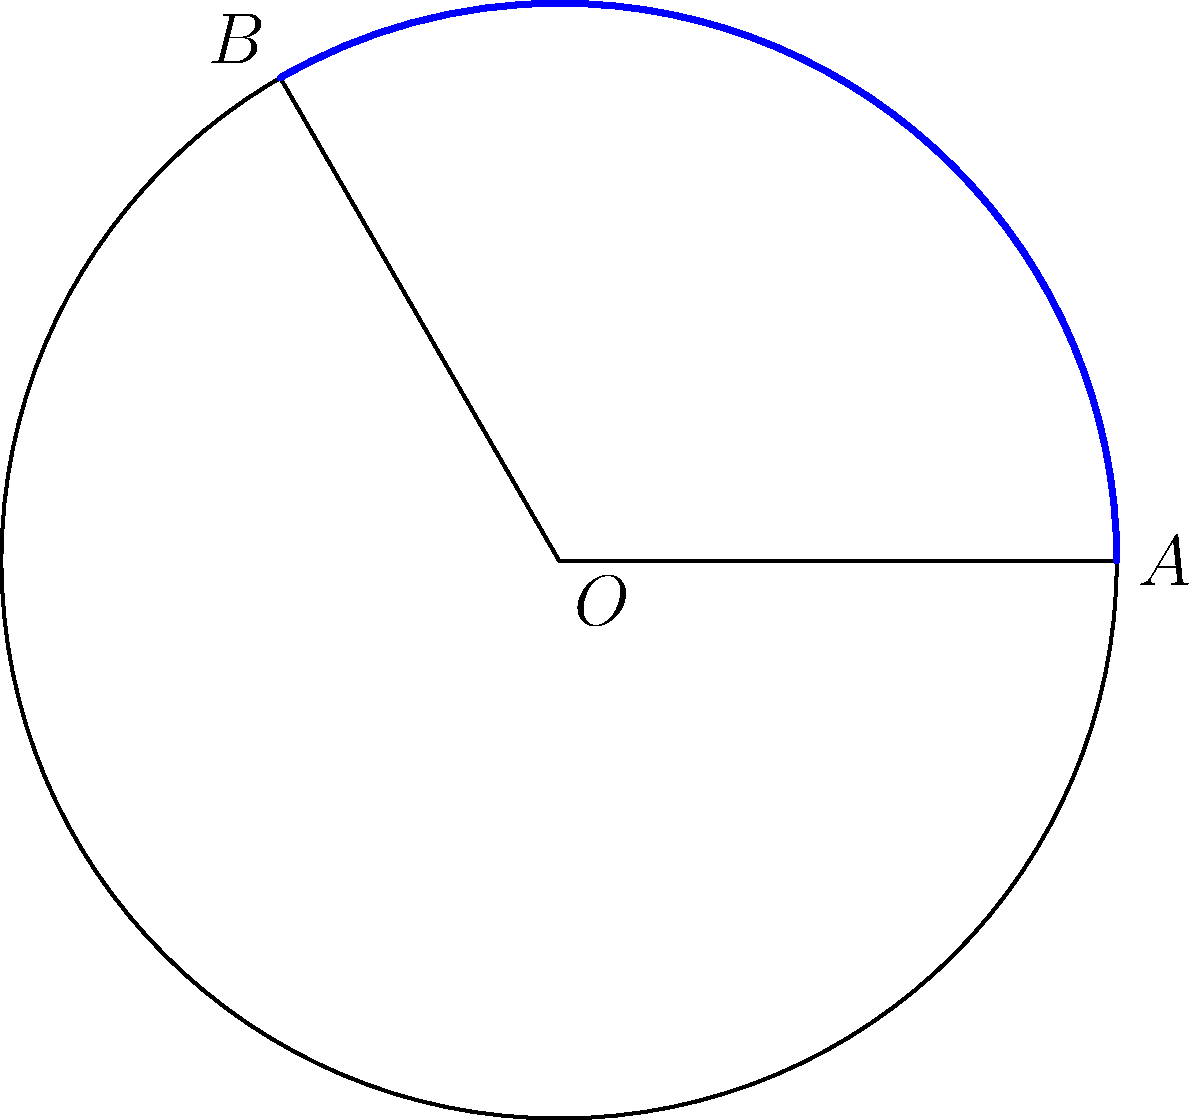In a swimming stroke analysis, the arc of a swimmer's hand movement is modeled as a circular segment. If the radius of this circular path is 0.75 meters and the central angle of the arc is 120°, what is the length of the arc (in meters) that the swimmer's hand travels during this portion of the stroke? To calculate the arc length, we can use the formula:

$$ s = r\theta $$

Where:
- $s$ is the arc length
- $r$ is the radius of the circle
- $\theta$ is the central angle in radians

Steps:
1) We have the radius $r = 0.75$ meters
2) The angle is given as 120°, but we need to convert it to radians:
   $$ \theta = 120° \times \frac{\pi}{180°} = \frac{2\pi}{3} \text{ radians} $$
3) Now we can substitute these values into our formula:
   $$ s = 0.75 \times \frac{2\pi}{3} $$
4) Simplify:
   $$ s = 0.5\pi \text{ meters} $$
5) To get a decimal approximation:
   $$ s \approx 1.57 \text{ meters} $$

Therefore, the swimmer's hand travels approximately 1.57 meters along this arc during the analyzed portion of the stroke.
Answer: $0.5\pi$ meters (or approximately 1.57 meters) 